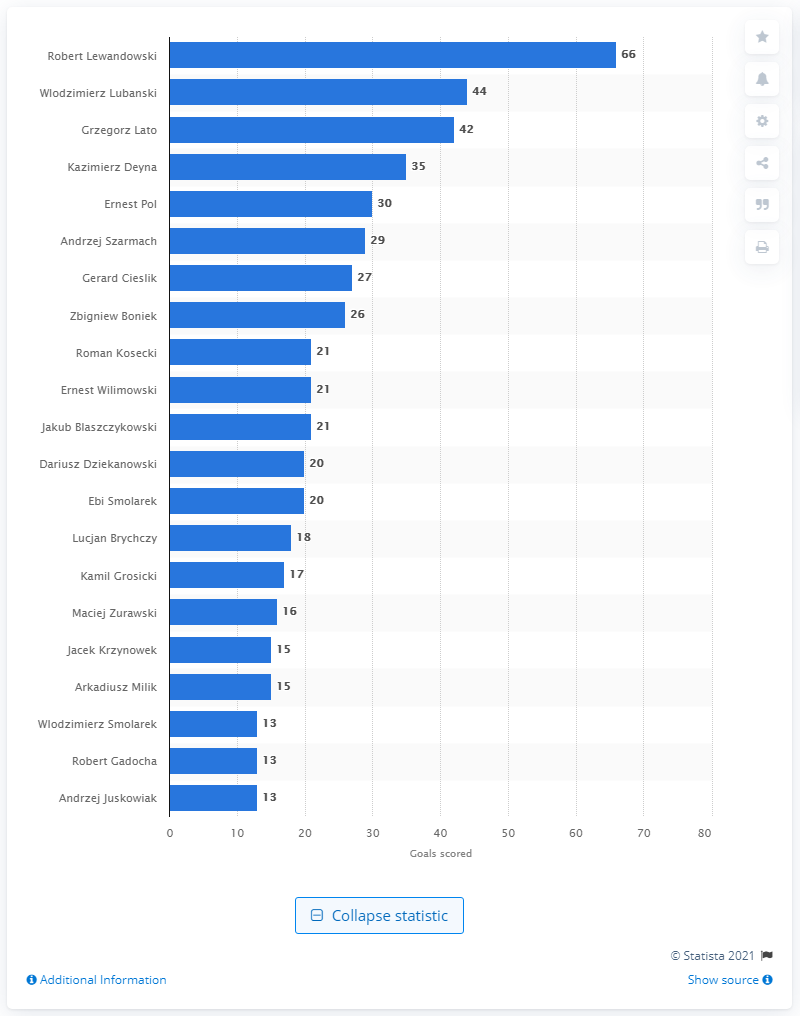List a handful of essential elements in this visual. In 2021, Robert Lewandowski scored a total of 66 goals for the national football team of Poland. Wlodzimierz Lubanski is the all-time leader in goals scored for the national football team of Poland. 